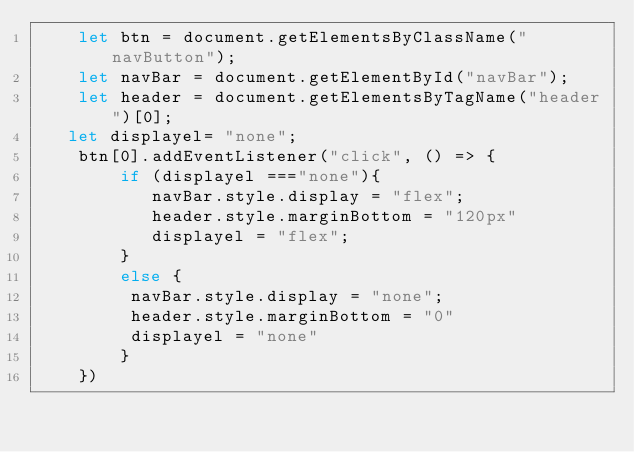Convert code to text. <code><loc_0><loc_0><loc_500><loc_500><_JavaScript_>    let btn = document.getElementsByClassName("navButton");
    let navBar = document.getElementById("navBar");
    let header = document.getElementsByTagName("header")[0];
   let displayel= "none";
    btn[0].addEventListener("click", () => {
        if (displayel ==="none"){
           navBar.style.display = "flex";
           header.style.marginBottom = "120px"
           displayel = "flex";
        }
        else {
         navBar.style.display = "none";
         header.style.marginBottom = "0"
         displayel = "none"
        }
    })
</code> 